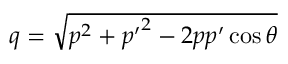Convert formula to latex. <formula><loc_0><loc_0><loc_500><loc_500>q = \sqrt { p ^ { 2 } + { p ^ { \prime } } ^ { 2 } - 2 p { p ^ { \prime } } \cos \theta }</formula> 